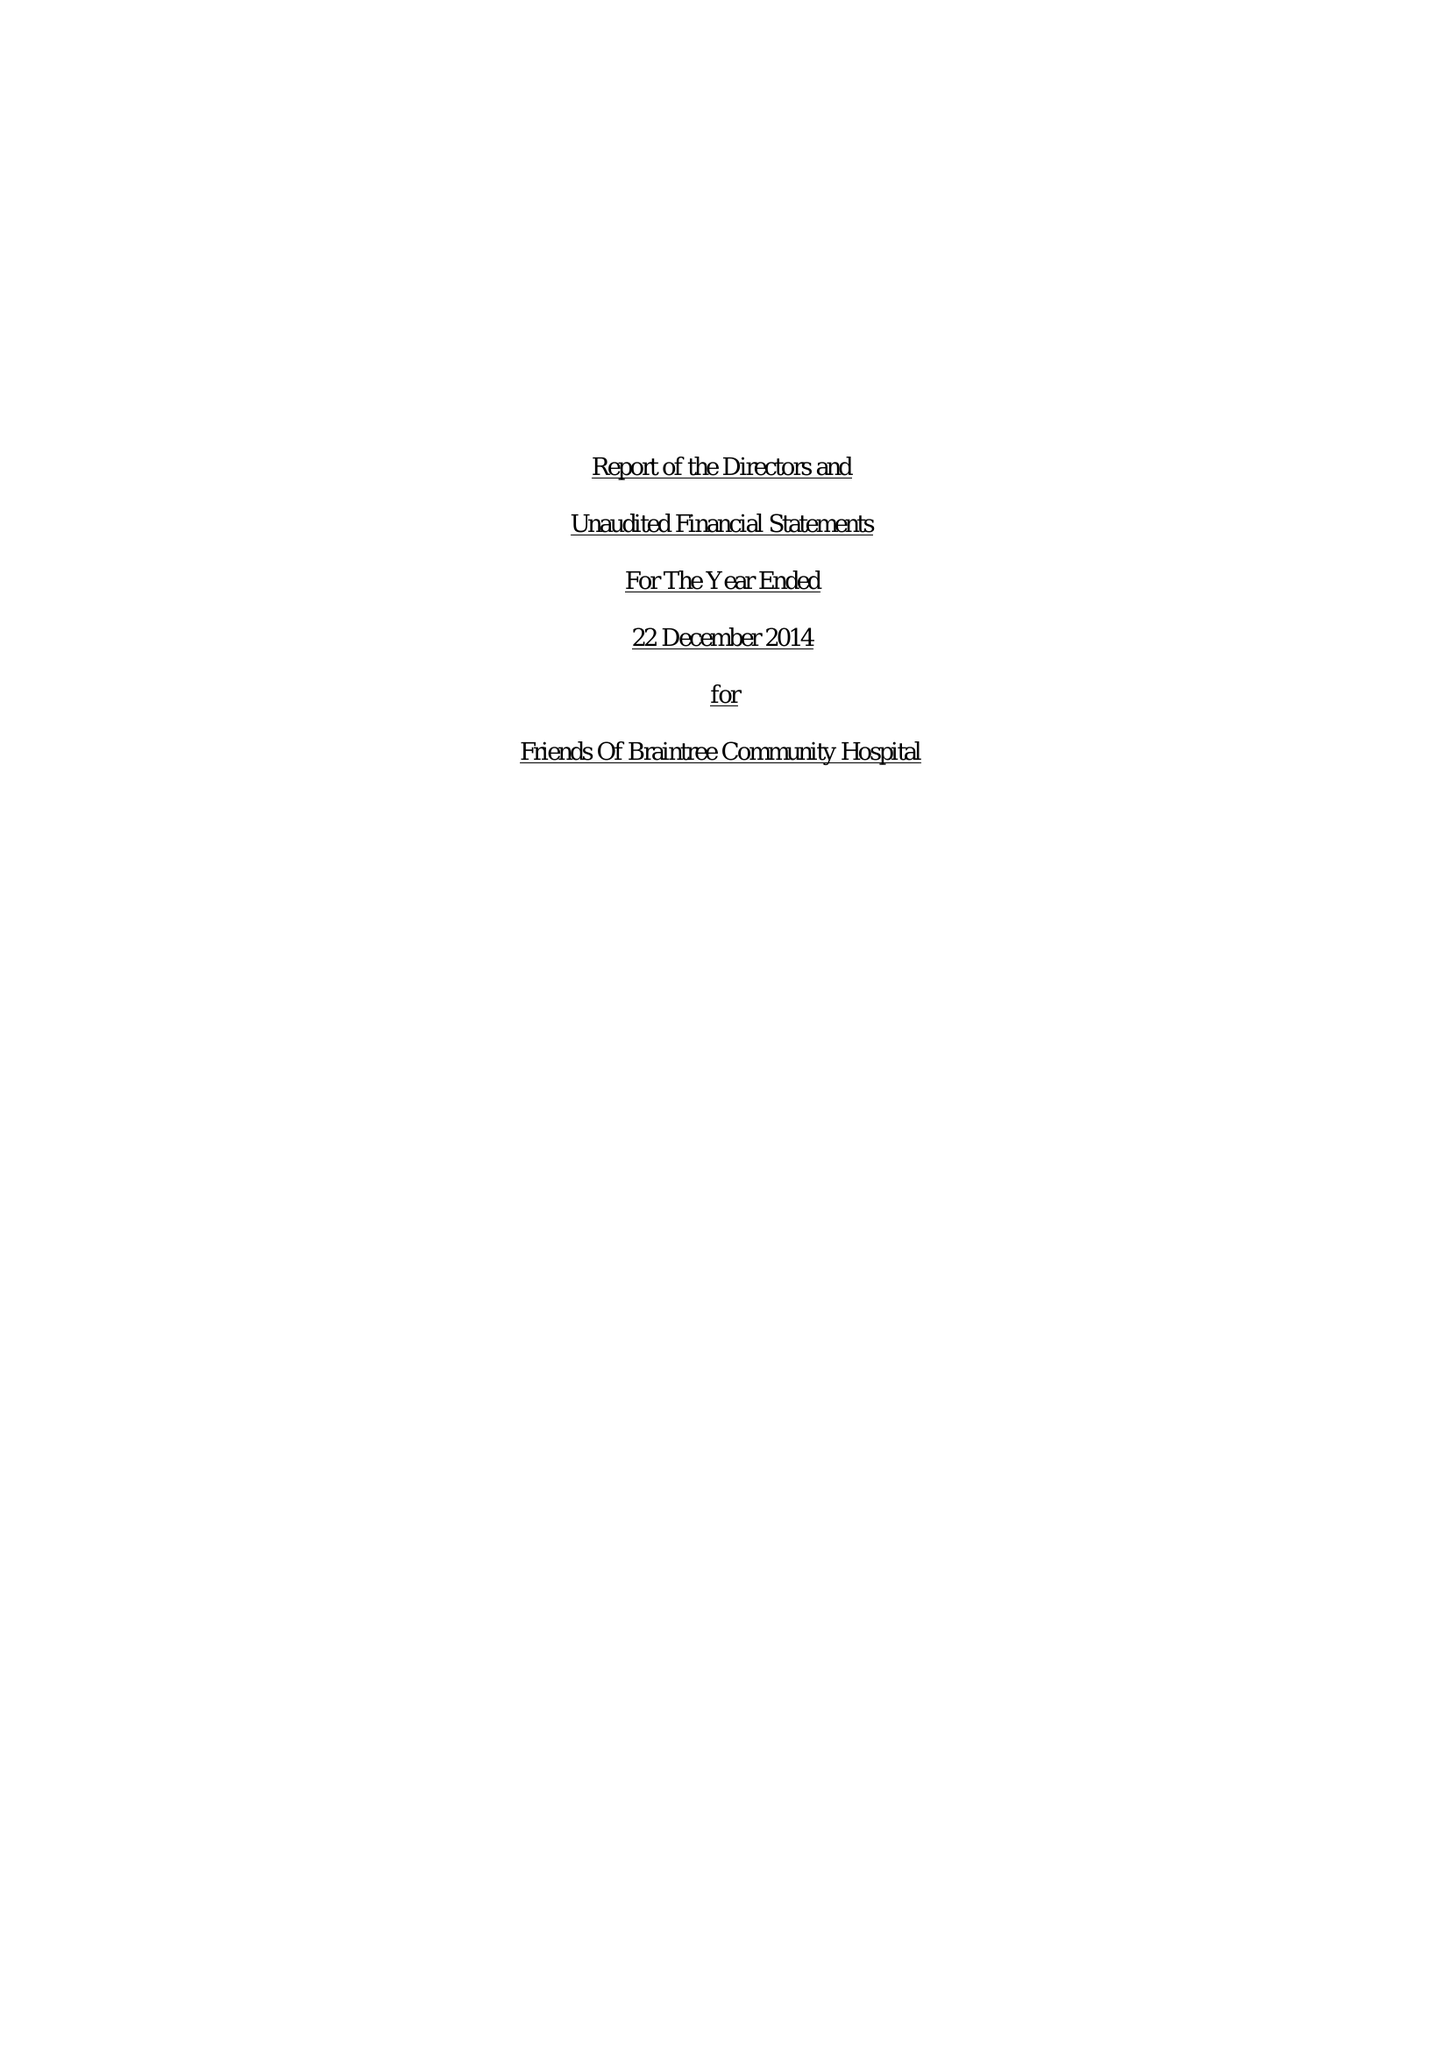What is the value for the income_annually_in_british_pounds?
Answer the question using a single word or phrase. 35186.00 